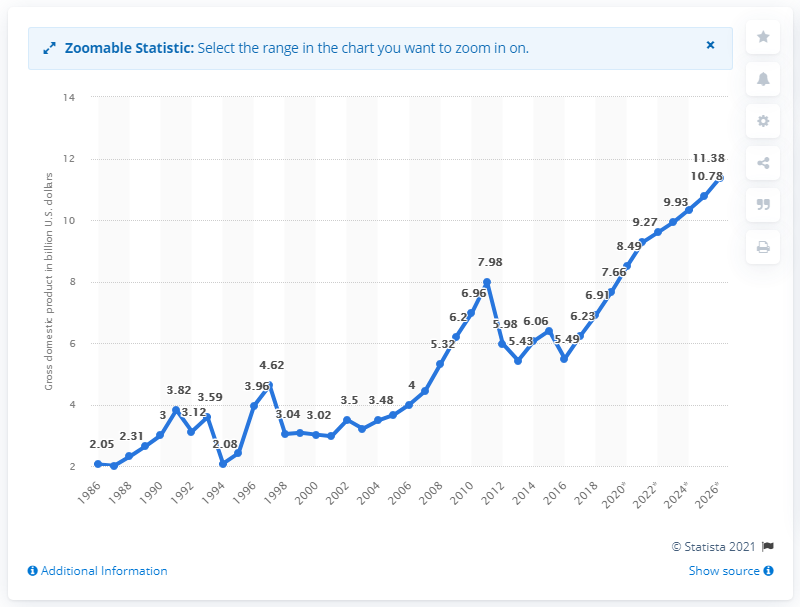Outline some significant characteristics in this image. In 2019, the gross domestic product of Malawi was estimated to be 7.66 billion dollars. 